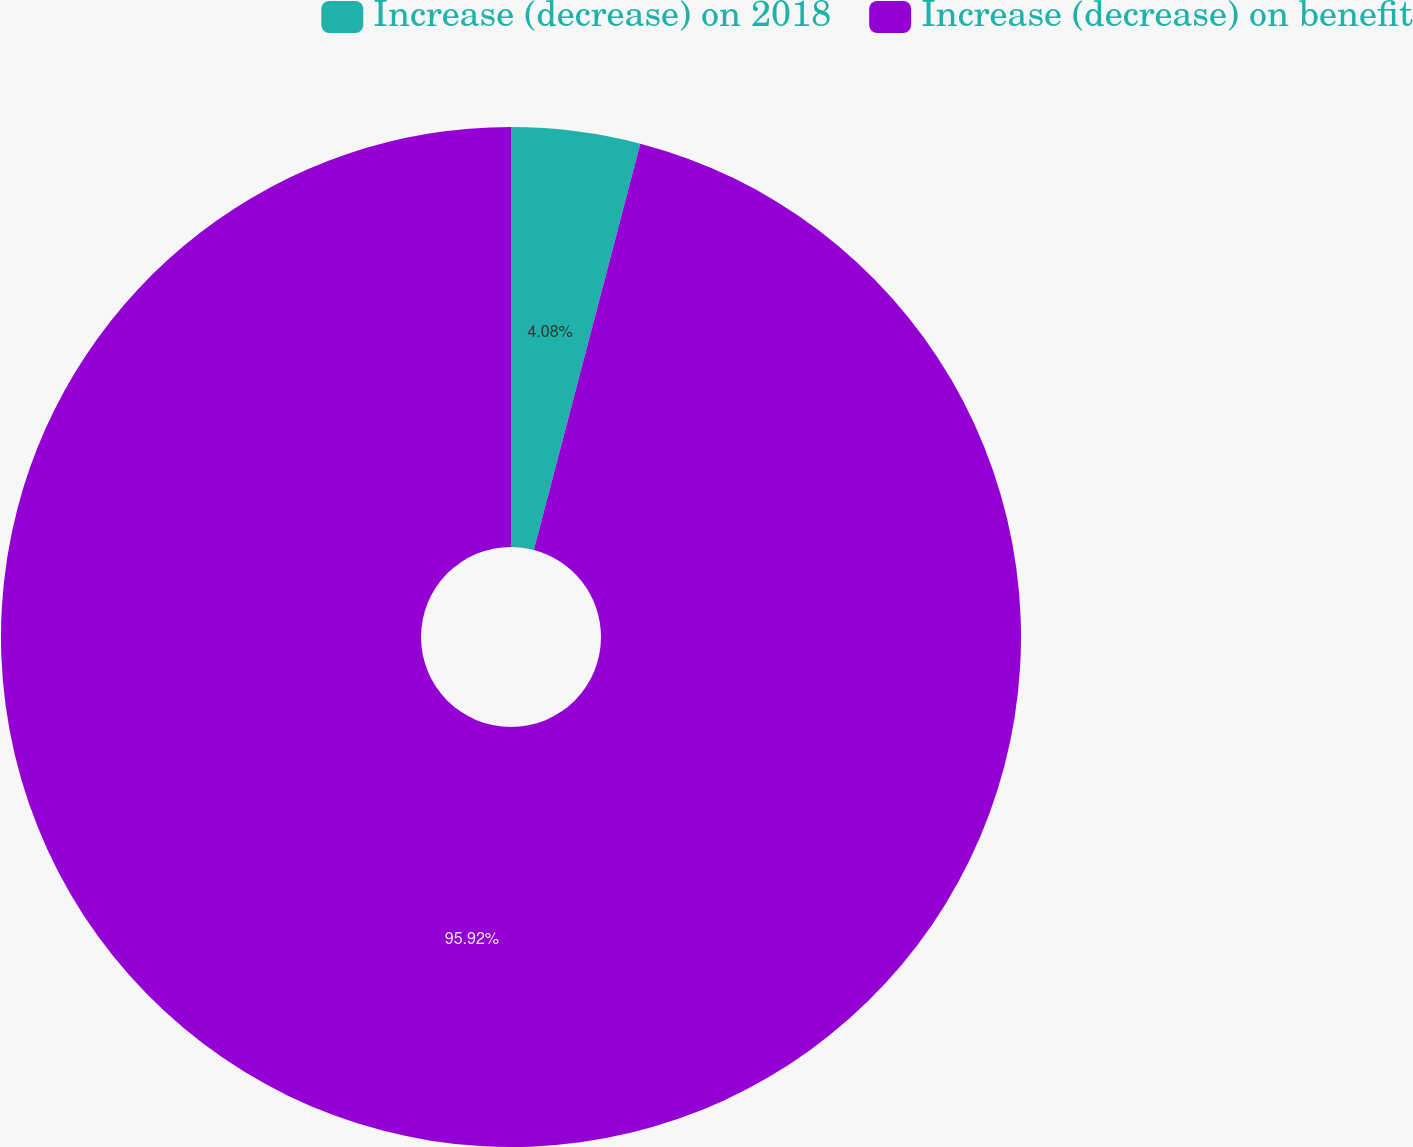Convert chart to OTSL. <chart><loc_0><loc_0><loc_500><loc_500><pie_chart><fcel>Increase (decrease) on 2018<fcel>Increase (decrease) on benefit<nl><fcel>4.08%<fcel>95.92%<nl></chart> 